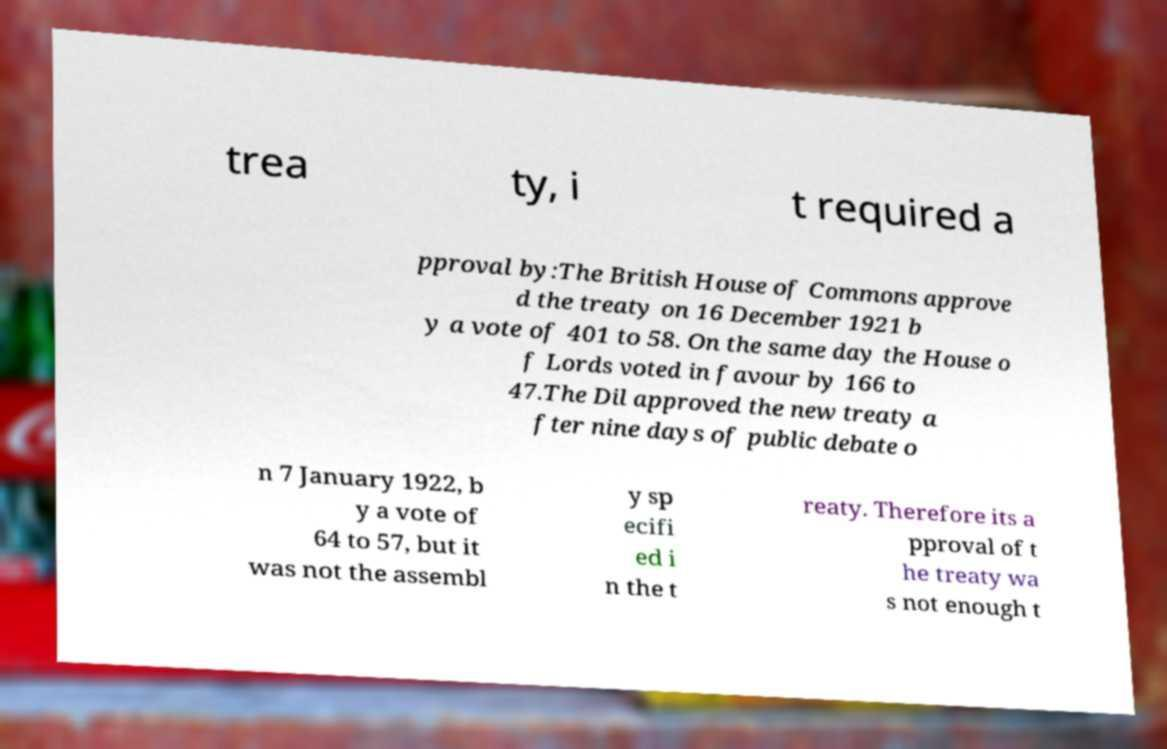What messages or text are displayed in this image? I need them in a readable, typed format. trea ty, i t required a pproval by:The British House of Commons approve d the treaty on 16 December 1921 b y a vote of 401 to 58. On the same day the House o f Lords voted in favour by 166 to 47.The Dil approved the new treaty a fter nine days of public debate o n 7 January 1922, b y a vote of 64 to 57, but it was not the assembl y sp ecifi ed i n the t reaty. Therefore its a pproval of t he treaty wa s not enough t 